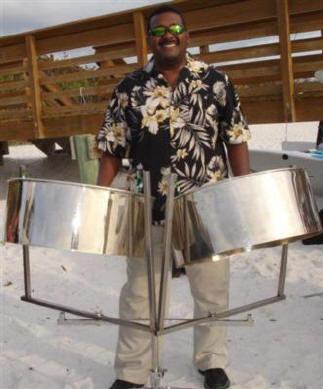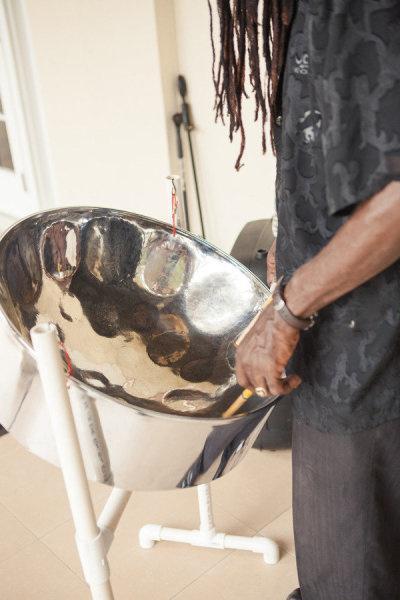The first image is the image on the left, the second image is the image on the right. Examine the images to the left and right. Is the description "At least one steel drum has drum sticks laying on top." accurate? Answer yes or no. No. The first image is the image on the left, the second image is the image on the right. Analyze the images presented: Is the assertion "In at least one image there is a total of two drums and one man playing them." valid? Answer yes or no. Yes. 